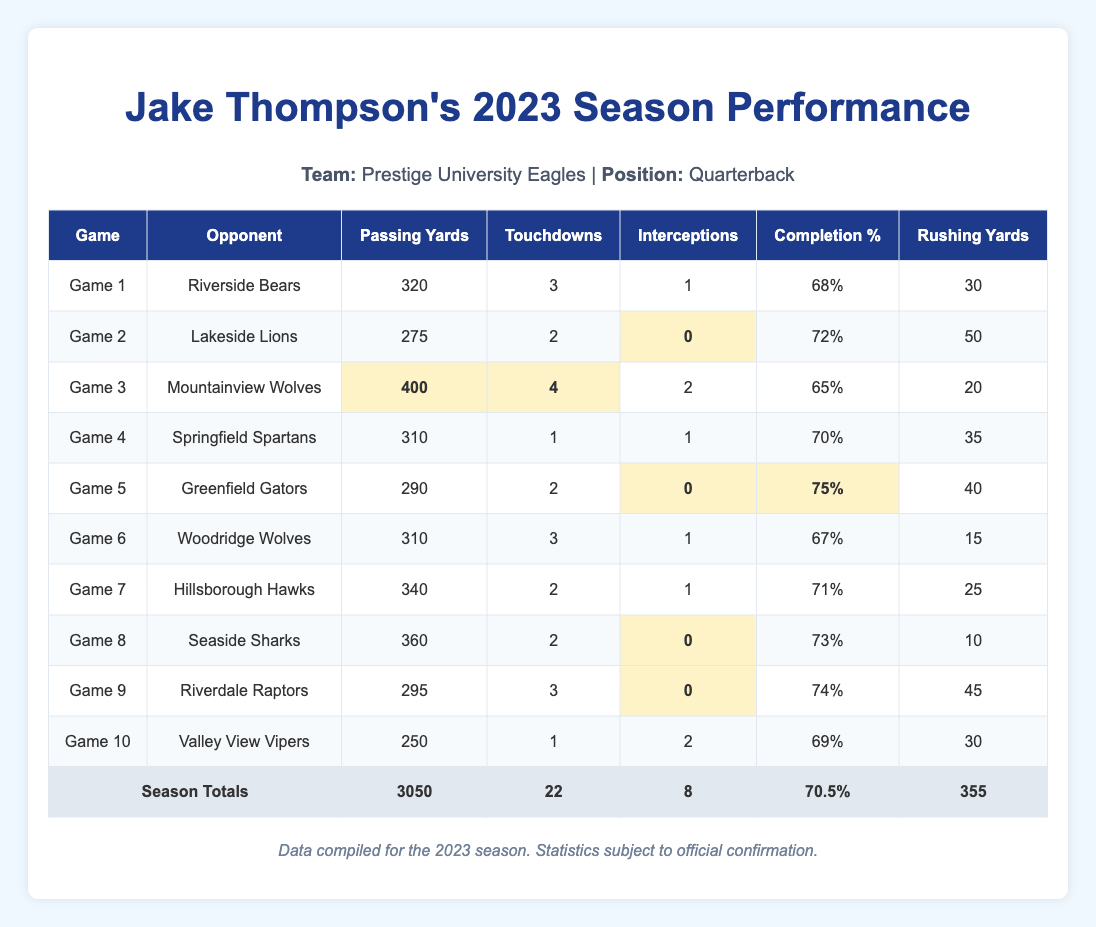What was Jake Thompson's highest passing yardage in a single game? The highest passing yardage in the table is 400 yards, which occurred in Game 3 against the Mountainview Wolves.
Answer: 400 yards How many touchdowns did Jake Thompson throw in Game 1? According to the table, Jake Thompson threw 3 touchdowns in Game 1 against the Riverside Bears.
Answer: 3 touchdowns What is Jake Thompson's total passing yards for the season? The total passing yards are found in the total statistics row at the end of the table, which shows 3050 yards.
Answer: 3050 yards In how many games did Jake Thompson have zero interceptions? From the table, he had zero interceptions in Games 2, 5, 8, and 9, which totals to 4 games.
Answer: 4 games What is the average completion percentage of Jake Thompson across the season? The average completion percentage is listed in the total statistics as 70.5%.
Answer: 70.5% Which game had the most touchdowns thrown by Jake Thompson? By examining the touchdowns column, Game 3 against the Mountainview Wolves had the most, with 4 touchdowns.
Answer: Game 3 What was the total number of rushing yards across all games? The total rushing yards is shown in the total statistics row at the bottom of the table, which indicates 355 yards.
Answer: 355 yards Did Jake Thompson complete more than 70% of his passes in Game 5? In Game 5 against the Greenfield Gators, the table shows he had a completion percentage of 75%, which is indeed more than 70%.
Answer: Yes How many touchdowns did he score in games against teams that did not have any interceptions? The games without interceptions where he threw touchdowns include Game 2, Game 5, Game 8, and Game 9, totaling 2 + 2 + 2 + 3 = 9 touchdowns.
Answer: 9 touchdowns What is the difference in passing yards between Game 1 and Game 10? The passing yards for Game 1 is 320 and for Game 10 is 250, so the difference is 320 - 250 = 70 yards.
Answer: 70 yards 